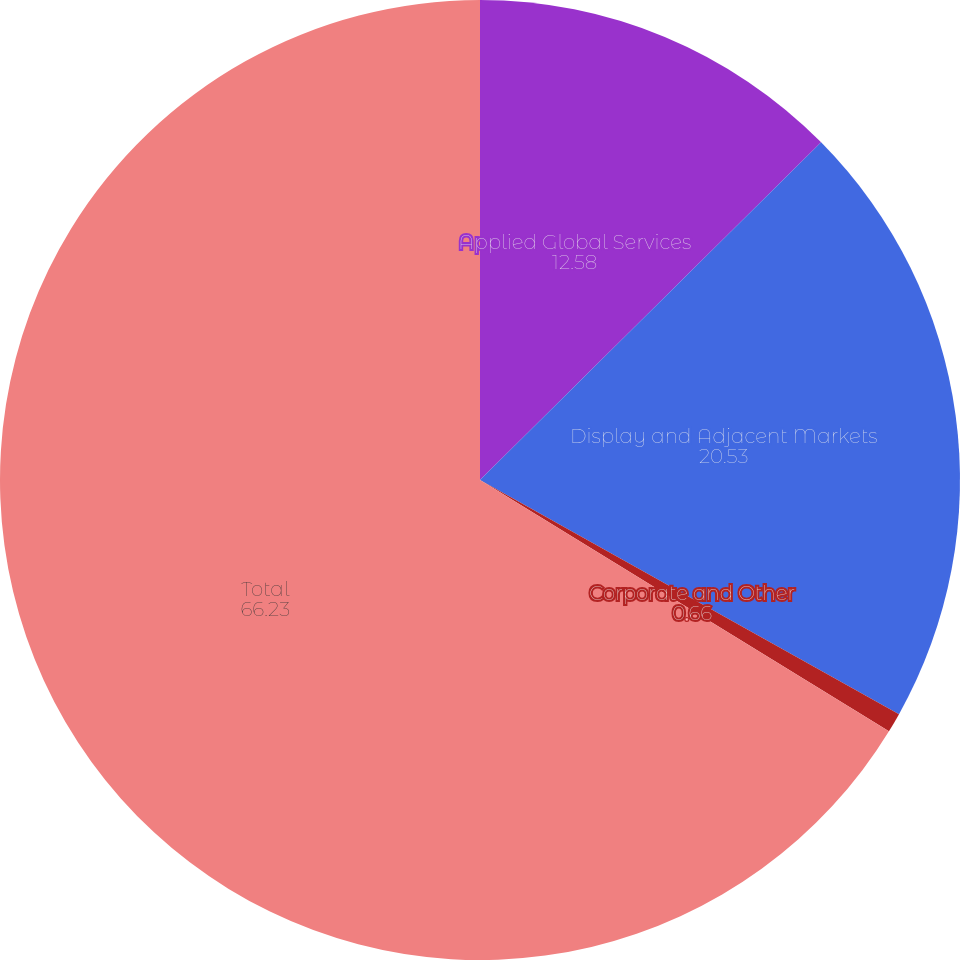Convert chart. <chart><loc_0><loc_0><loc_500><loc_500><pie_chart><fcel>Applied Global Services<fcel>Display and Adjacent Markets<fcel>Corporate and Other<fcel>Total<nl><fcel>12.58%<fcel>20.53%<fcel>0.66%<fcel>66.23%<nl></chart> 